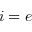<formula> <loc_0><loc_0><loc_500><loc_500>i = e</formula> 